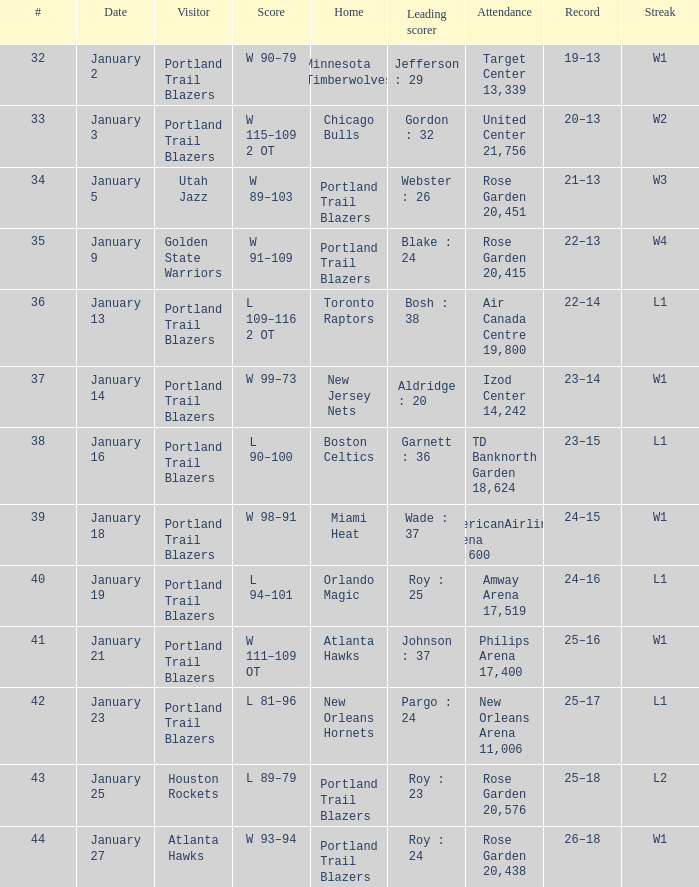Could you parse the entire table? {'header': ['#', 'Date', 'Visitor', 'Score', 'Home', 'Leading scorer', 'Attendance', 'Record', 'Streak'], 'rows': [['32', 'January 2', 'Portland Trail Blazers', 'W 90–79', 'Minnesota Timberwolves', 'Jefferson : 29', 'Target Center 13,339', '19–13', 'W1'], ['33', 'January 3', 'Portland Trail Blazers', 'W 115–109 2 OT', 'Chicago Bulls', 'Gordon : 32', 'United Center 21,756', '20–13', 'W2'], ['34', 'January 5', 'Utah Jazz', 'W 89–103', 'Portland Trail Blazers', 'Webster : 26', 'Rose Garden 20,451', '21–13', 'W3'], ['35', 'January 9', 'Golden State Warriors', 'W 91–109', 'Portland Trail Blazers', 'Blake : 24', 'Rose Garden 20,415', '22–13', 'W4'], ['36', 'January 13', 'Portland Trail Blazers', 'L 109–116 2 OT', 'Toronto Raptors', 'Bosh : 38', 'Air Canada Centre 19,800', '22–14', 'L1'], ['37', 'January 14', 'Portland Trail Blazers', 'W 99–73', 'New Jersey Nets', 'Aldridge : 20', 'Izod Center 14,242', '23–14', 'W1'], ['38', 'January 16', 'Portland Trail Blazers', 'L 90–100', 'Boston Celtics', 'Garnett : 36', 'TD Banknorth Garden 18,624', '23–15', 'L1'], ['39', 'January 18', 'Portland Trail Blazers', 'W 98–91', 'Miami Heat', 'Wade : 37', 'AmericanAirlines Arena 19,600', '24–15', 'W1'], ['40', 'January 19', 'Portland Trail Blazers', 'L 94–101', 'Orlando Magic', 'Roy : 25', 'Amway Arena 17,519', '24–16', 'L1'], ['41', 'January 21', 'Portland Trail Blazers', 'W 111–109 OT', 'Atlanta Hawks', 'Johnson : 37', 'Philips Arena 17,400', '25–16', 'W1'], ['42', 'January 23', 'Portland Trail Blazers', 'L 81–96', 'New Orleans Hornets', 'Pargo : 24', 'New Orleans Arena 11,006', '25–17', 'L1'], ['43', 'January 25', 'Houston Rockets', 'L 89–79', 'Portland Trail Blazers', 'Roy : 23', 'Rose Garden 20,576', '25–18', 'L2'], ['44', 'January 27', 'Atlanta Hawks', 'W 93–94', 'Portland Trail Blazers', 'Roy : 24', 'Rose Garden 20,438', '26–18', 'W1']]} What records have a score of l 109–116 2 ot 22–14. 